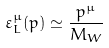Convert formula to latex. <formula><loc_0><loc_0><loc_500><loc_500>\varepsilon ^ { \mu } _ { L } ( p ) \simeq \frac { p ^ { \mu } } { M _ { W } }</formula> 